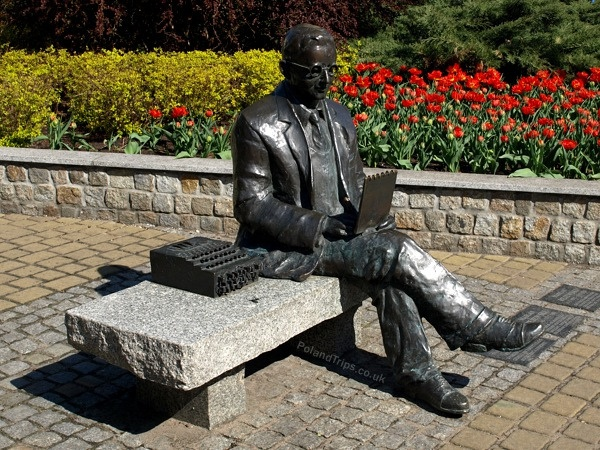Describe the objects in this image and their specific colors. I can see bench in black, darkgray, and lightgray tones, tie in black and gray tones, and laptop in black and gray tones in this image. 